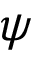<formula> <loc_0><loc_0><loc_500><loc_500>\psi</formula> 